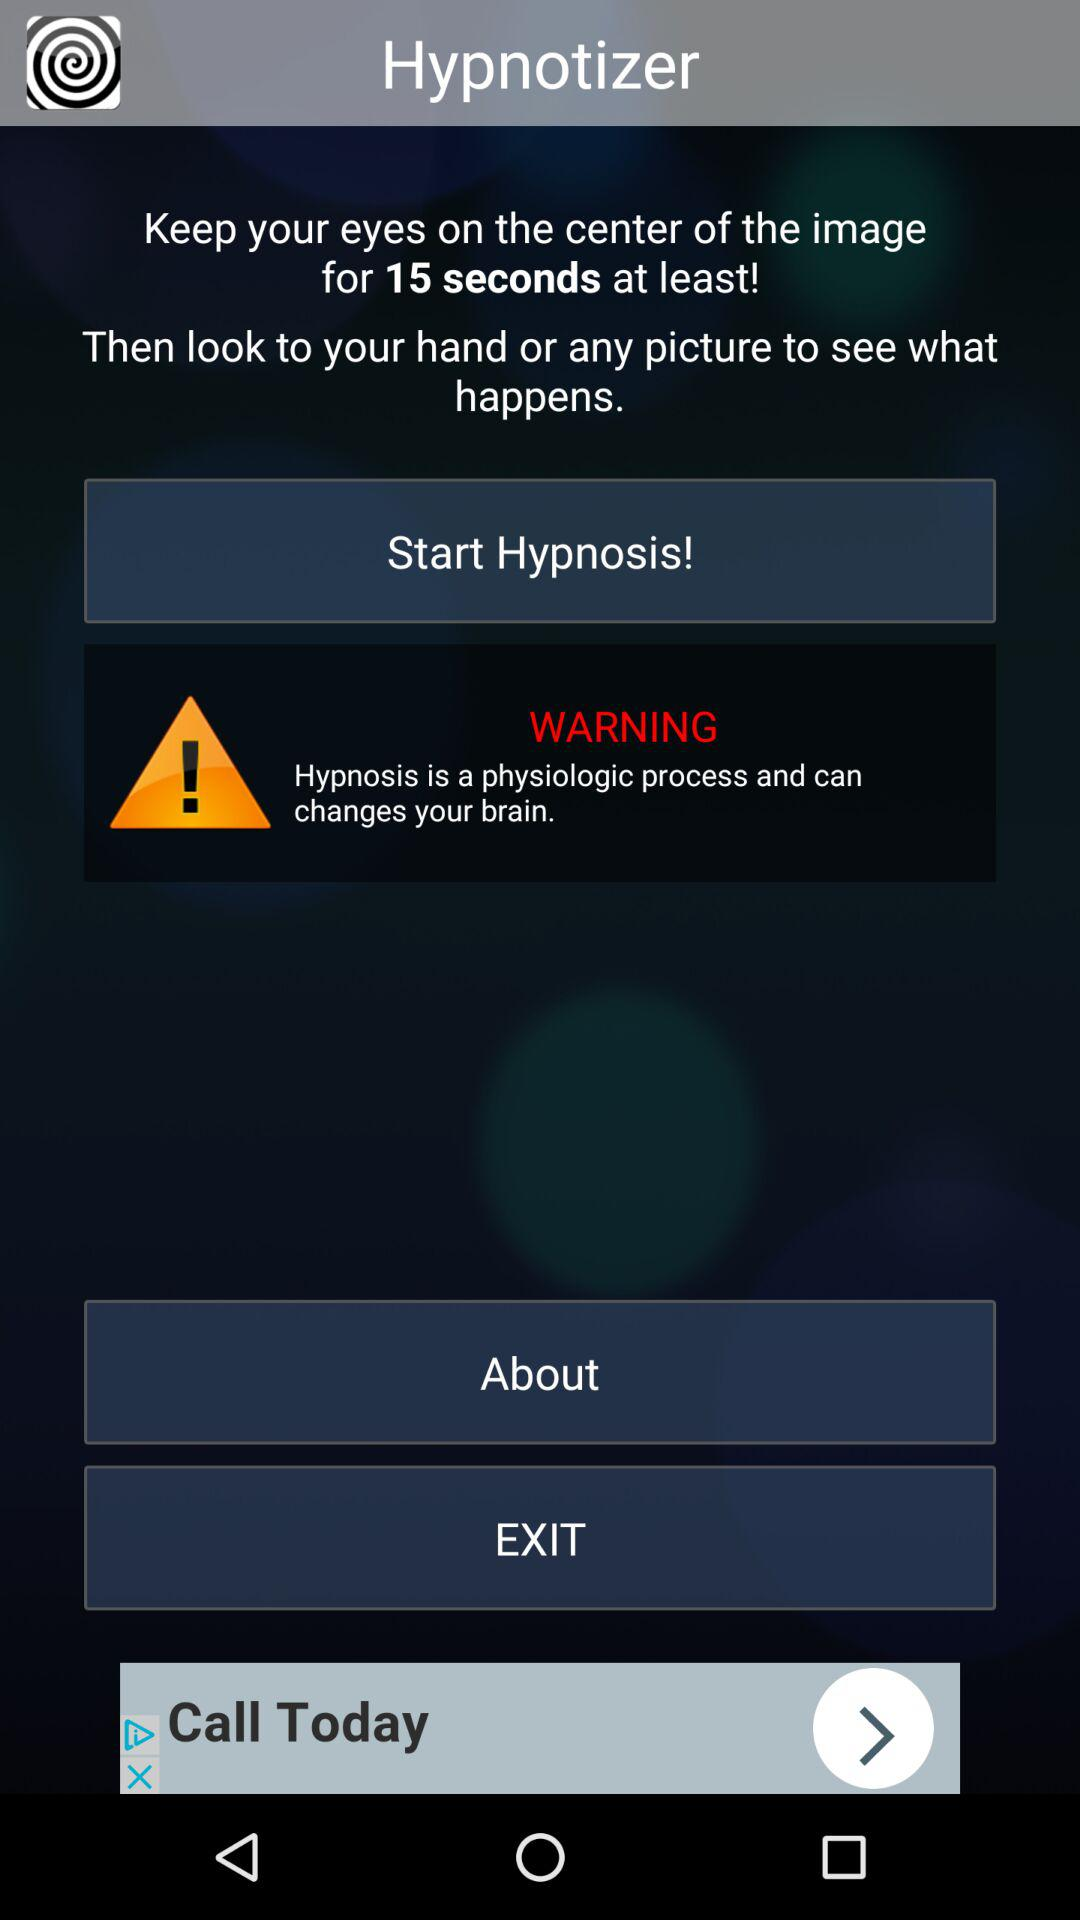For how long do we need to keep our eyes on the image? You need to keep your eyes on the image for at least 15 seconds. 